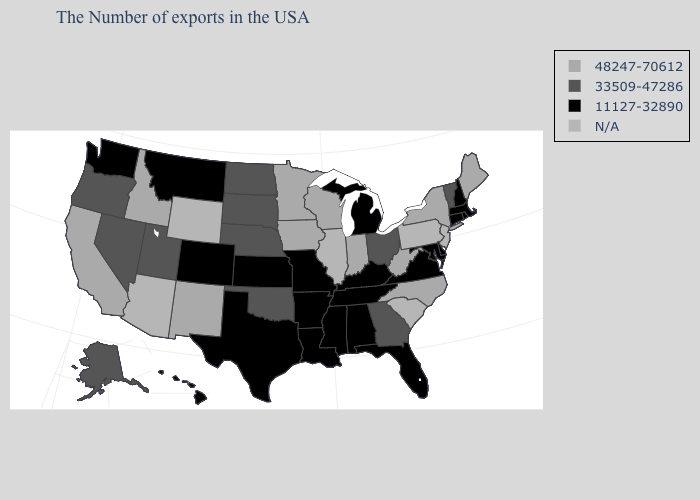Which states hav the highest value in the Northeast?
Short answer required. Maine, New York. Does the first symbol in the legend represent the smallest category?
Concise answer only. No. What is the value of Arizona?
Quick response, please. N/A. Does the first symbol in the legend represent the smallest category?
Concise answer only. No. Name the states that have a value in the range 48247-70612?
Short answer required. Maine, New York, North Carolina, West Virginia, Indiana, Wisconsin, Minnesota, Iowa, New Mexico, Idaho, California. Does the first symbol in the legend represent the smallest category?
Short answer required. No. Does Washington have the lowest value in the West?
Give a very brief answer. Yes. Name the states that have a value in the range N/A?
Concise answer only. New Jersey, Pennsylvania, South Carolina, Illinois, Wyoming, Arizona. Name the states that have a value in the range 33509-47286?
Write a very short answer. Vermont, Ohio, Georgia, Nebraska, Oklahoma, South Dakota, North Dakota, Utah, Nevada, Oregon, Alaska. What is the value of North Dakota?
Concise answer only. 33509-47286. What is the highest value in the USA?
Give a very brief answer. 48247-70612. Name the states that have a value in the range 33509-47286?
Short answer required. Vermont, Ohio, Georgia, Nebraska, Oklahoma, South Dakota, North Dakota, Utah, Nevada, Oregon, Alaska. Does California have the lowest value in the West?
Keep it brief. No. What is the value of Illinois?
Write a very short answer. N/A. 